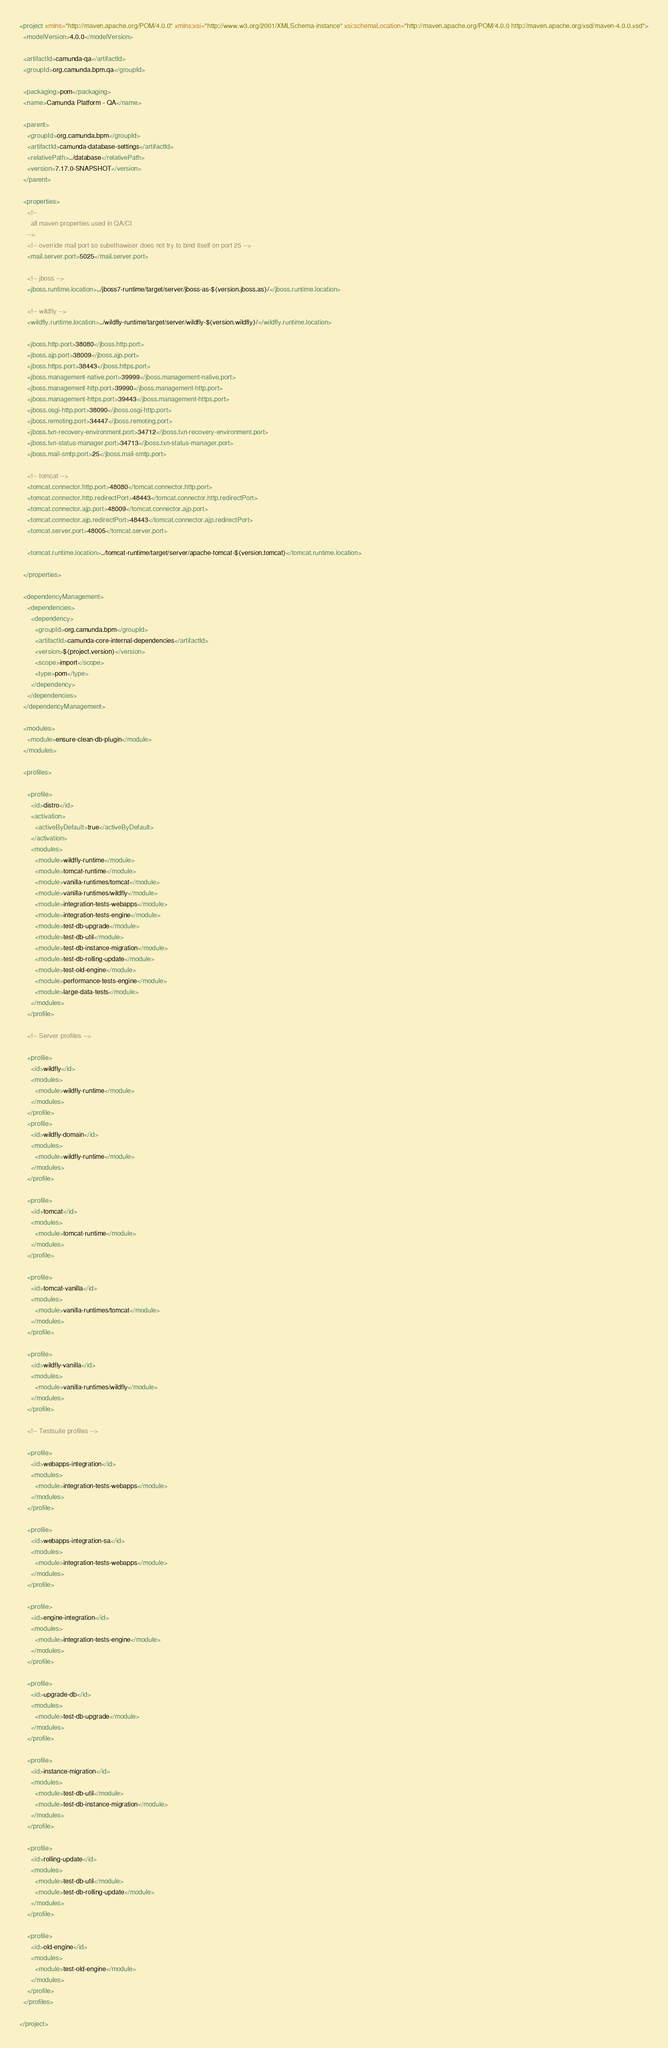<code> <loc_0><loc_0><loc_500><loc_500><_XML_><project xmlns="http://maven.apache.org/POM/4.0.0" xmlns:xsi="http://www.w3.org/2001/XMLSchema-instance" xsi:schemaLocation="http://maven.apache.org/POM/4.0.0 http://maven.apache.org/xsd/maven-4.0.0.xsd">
  <modelVersion>4.0.0</modelVersion>

  <artifactId>camunda-qa</artifactId>
  <groupId>org.camunda.bpm.qa</groupId>

  <packaging>pom</packaging>
  <name>Camunda Platform - QA</name>

  <parent>
    <groupId>org.camunda.bpm</groupId>
    <artifactId>camunda-database-settings</artifactId>
    <relativePath>../database</relativePath>
    <version>7.17.0-SNAPSHOT</version>
  </parent>

  <properties>
    <!--
      all maven properties used in QA/CI
    -->
    <!-- override mail port so subethawiser does not try to bind itself on port 25 -->
    <mail.server.port>5025</mail.server.port>

    <!-- jboss -->
    <jboss.runtime.location>../jboss7-runtime/target/server/jboss-as-${version.jboss.as}/</jboss.runtime.location>

    <!-- wildfly -->
    <wildfly.runtime.location>../wildfly-runtime/target/server/wildfly-${version.wildfly}/</wildfly.runtime.location>

    <jboss.http.port>38080</jboss.http.port>
    <jboss.ajp.port>38009</jboss.ajp.port>
    <jboss.https.port>38443</jboss.https.port>
    <jboss.management-native.port>39999</jboss.management-native.port>
    <jboss.management-http.port>39990</jboss.management-http.port>
    <jboss.management-https.port>39443</jboss.management-https.port>
    <jboss.osgi-http.port>38090</jboss.osgi-http.port>
    <jboss.remoting.port>34447</jboss.remoting.port>
    <jboss.txn-recovery-environment.port>34712</jboss.txn-recovery-environment.port>
    <jboss.txn-status-manager.port>34713</jboss.txn-status-manager.port>
    <jboss.mail-smtp.port>25</jboss.mail-smtp.port>

    <!-- tomcat -->
    <tomcat.connector.http.port>48080</tomcat.connector.http.port>
    <tomcat.connector.http.redirectPort>48443</tomcat.connector.http.redirectPort>
    <tomcat.connector.ajp.port>48009</tomcat.connector.ajp.port>
    <tomcat.connector.ajp.redirectPort>48443</tomcat.connector.ajp.redirectPort>
    <tomcat.server.port>48005</tomcat.server.port>

    <tomcat.runtime.location>../tomcat-runtime/target/server/apache-tomcat-${version.tomcat}</tomcat.runtime.location>

  </properties>

  <dependencyManagement>
    <dependencies>
      <dependency>
        <groupId>org.camunda.bpm</groupId>
        <artifactId>camunda-core-internal-dependencies</artifactId>
        <version>${project.version}</version>
        <scope>import</scope>
        <type>pom</type>
      </dependency>
    </dependencies>
  </dependencyManagement>

  <modules>
    <module>ensure-clean-db-plugin</module>
  </modules>

  <profiles>

    <profile>
      <id>distro</id>
      <activation>
        <activeByDefault>true</activeByDefault>
      </activation>
      <modules>
        <module>wildfly-runtime</module>
        <module>tomcat-runtime</module>
        <module>vanilla-runtimes/tomcat</module>
        <module>vanilla-runtimes/wildfly</module>
        <module>integration-tests-webapps</module>
        <module>integration-tests-engine</module>
        <module>test-db-upgrade</module>
        <module>test-db-util</module>
        <module>test-db-instance-migration</module>
        <module>test-db-rolling-update</module>
        <module>test-old-engine</module>
        <module>performance-tests-engine</module>
        <module>large-data-tests</module>
      </modules>
    </profile>

    <!-- Server profiles -->

    <profile>
      <id>wildfly</id>
      <modules>
        <module>wildfly-runtime</module>
      </modules>
    </profile>
    <profile>
      <id>wildfly-domain</id>
      <modules>
        <module>wildfly-runtime</module>
      </modules>
    </profile>

    <profile>
      <id>tomcat</id>
      <modules>
        <module>tomcat-runtime</module>
      </modules>
    </profile>

    <profile>
      <id>tomcat-vanilla</id>
      <modules>
        <module>vanilla-runtimes/tomcat</module>
      </modules>
    </profile>

    <profile>
      <id>wildfly-vanilla</id>
      <modules>
        <module>vanilla-runtimes/wildfly</module>
      </modules>
    </profile>

    <!-- Testsuite profiles -->

    <profile>
      <id>webapps-integration</id>
      <modules>
        <module>integration-tests-webapps</module>
      </modules>
    </profile>

    <profile>
      <id>webapps-integration-sa</id>
      <modules>
        <module>integration-tests-webapps</module>
      </modules>
    </profile>

    <profile>
      <id>engine-integration</id>
      <modules>
        <module>integration-tests-engine</module>
      </modules>
    </profile>

    <profile>
      <id>upgrade-db</id>
      <modules>
        <module>test-db-upgrade</module>
      </modules>
    </profile>

    <profile>
      <id>instance-migration</id>
      <modules>
        <module>test-db-util</module>
        <module>test-db-instance-migration</module>
      </modules>
    </profile>

    <profile>
      <id>rolling-update</id>
      <modules>
        <module>test-db-util</module>
        <module>test-db-rolling-update</module>
      </modules>
    </profile>

    <profile>
      <id>old-engine</id>
      <modules>
        <module>test-old-engine</module>
      </modules>
    </profile>
  </profiles>

</project>
</code> 